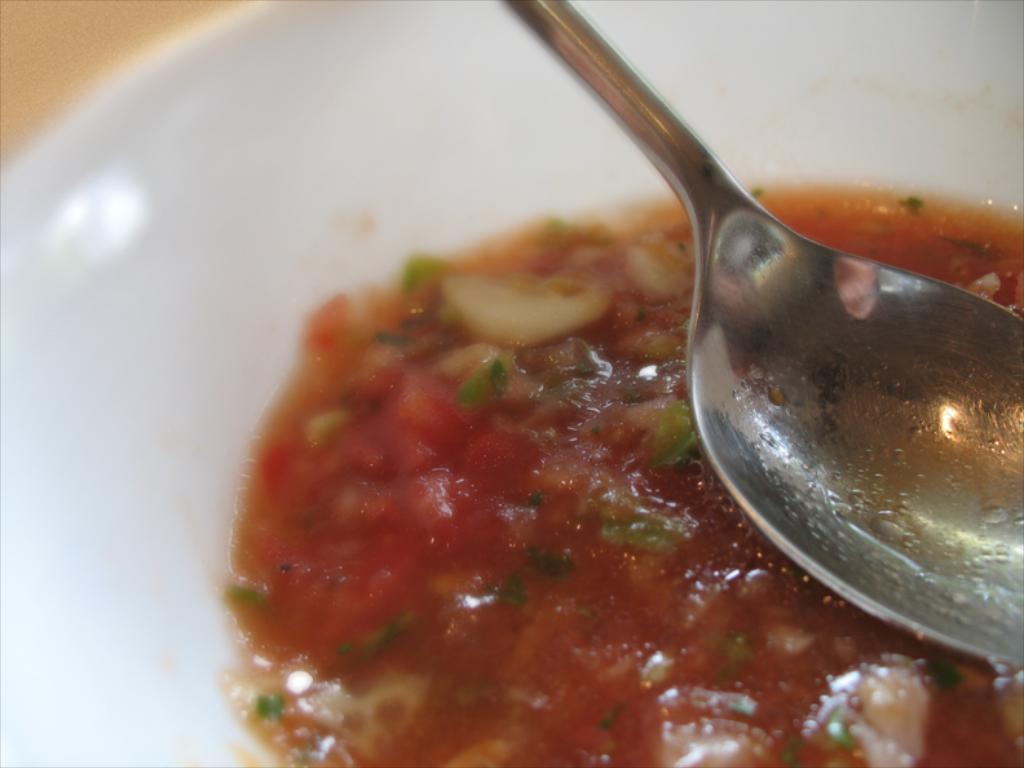What is present on the plate in the image? There is food in the plate. What utensil is placed with the food on the plate? There is a spoon in the plate. What might someone be about to do with the spoon and food? Someone might be about to eat the food with the spoon. What type of credit can be seen on the plate in the image? There is no credit present on the plate in the image. How much does the quarter cost in the image? There is no quarter present in the image. 